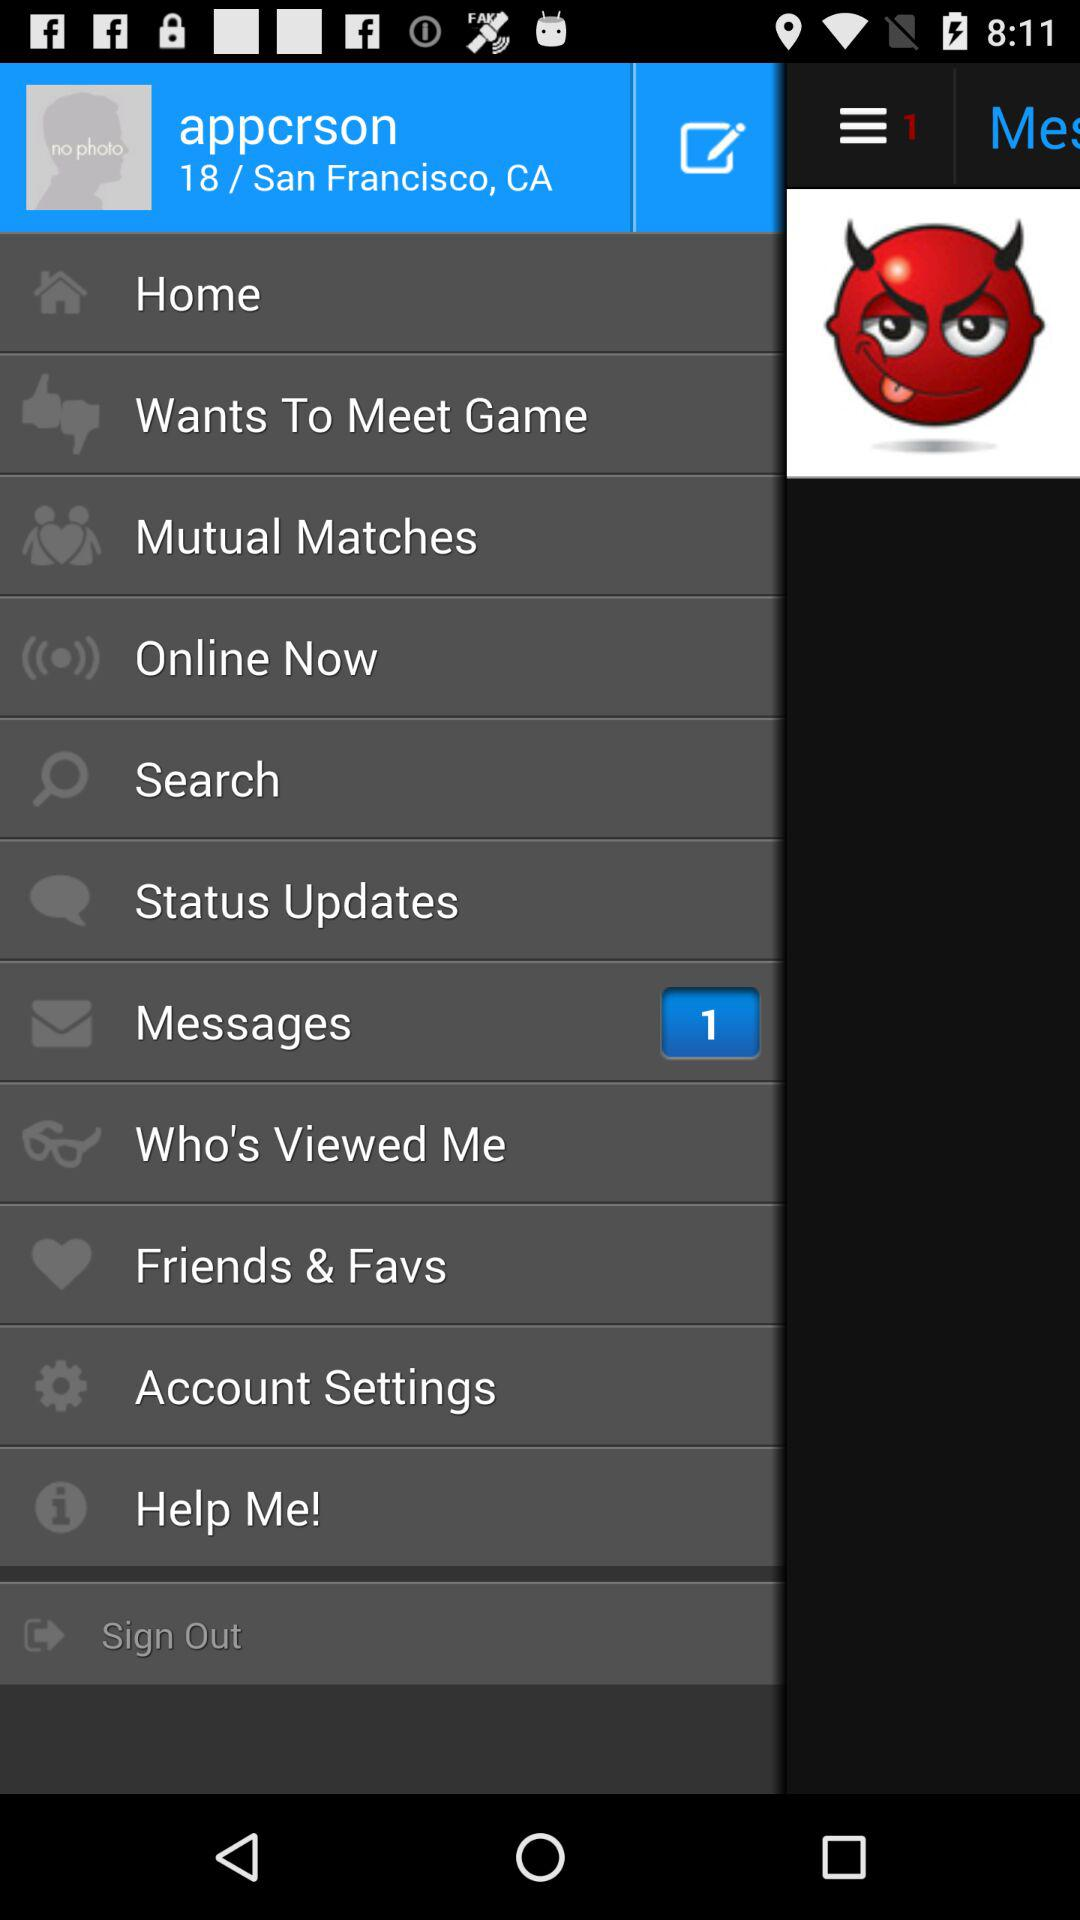What is the username? The username is "appcrson". 